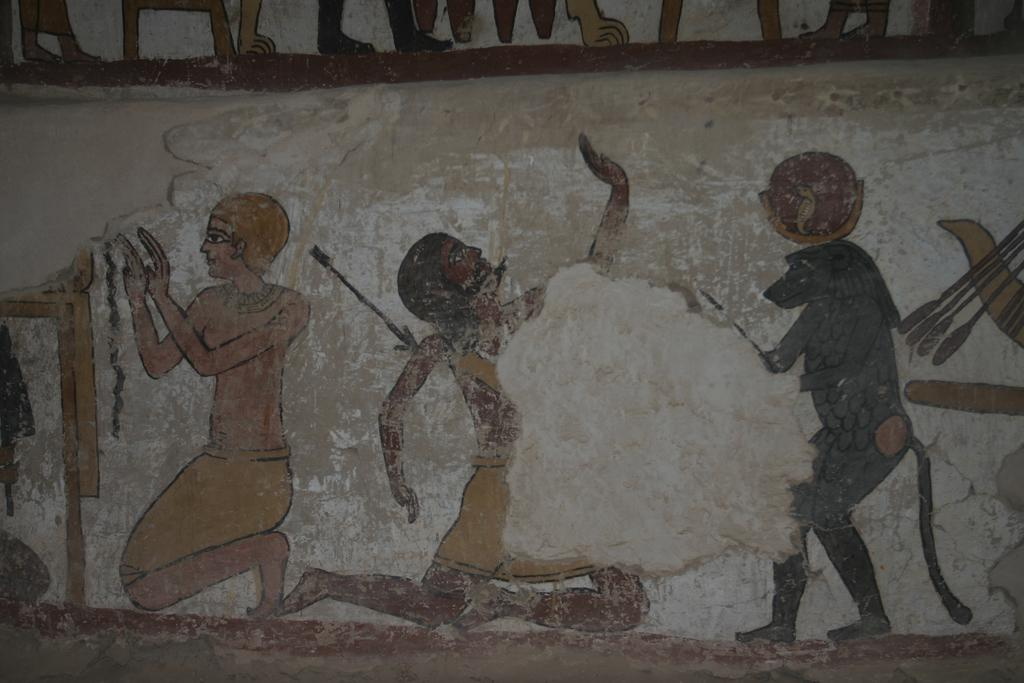What is the main feature of the image? There is a wall in the image. What can be seen on the wall? Paintings of people are present on the wall. What type of steel plate is used to create the paintings on the wall? There is no mention of steel or plates in the image; the paintings are simply on the wall. 